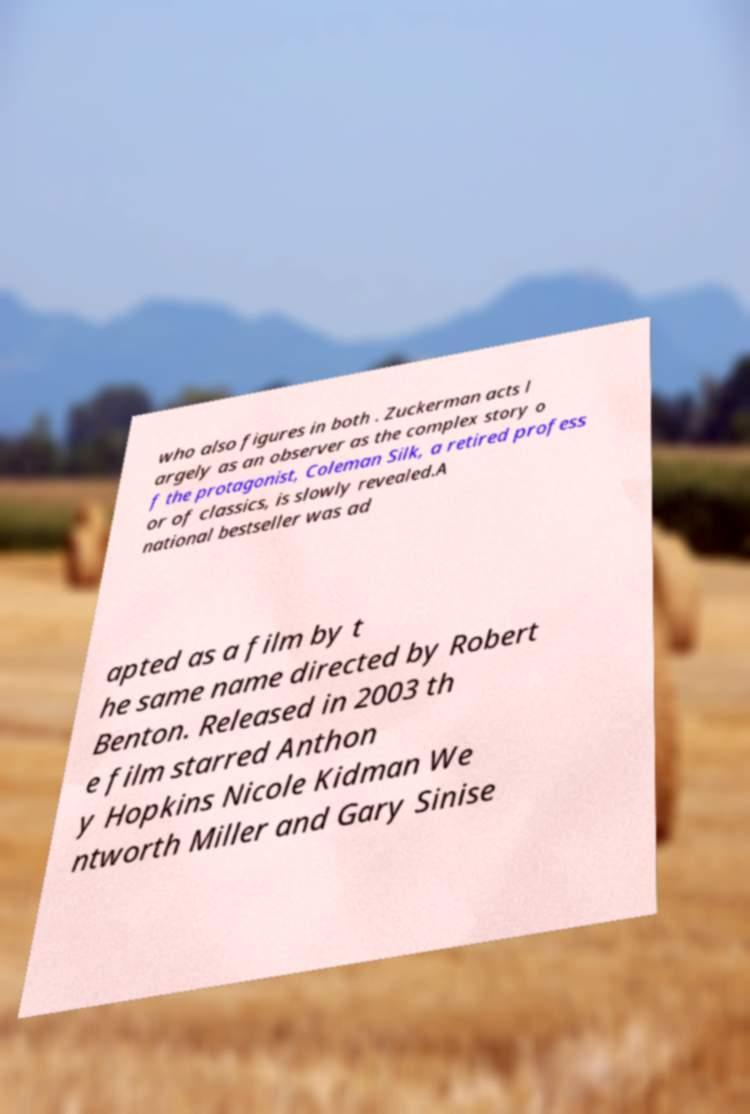Can you accurately transcribe the text from the provided image for me? who also figures in both . Zuckerman acts l argely as an observer as the complex story o f the protagonist, Coleman Silk, a retired profess or of classics, is slowly revealed.A national bestseller was ad apted as a film by t he same name directed by Robert Benton. Released in 2003 th e film starred Anthon y Hopkins Nicole Kidman We ntworth Miller and Gary Sinise 